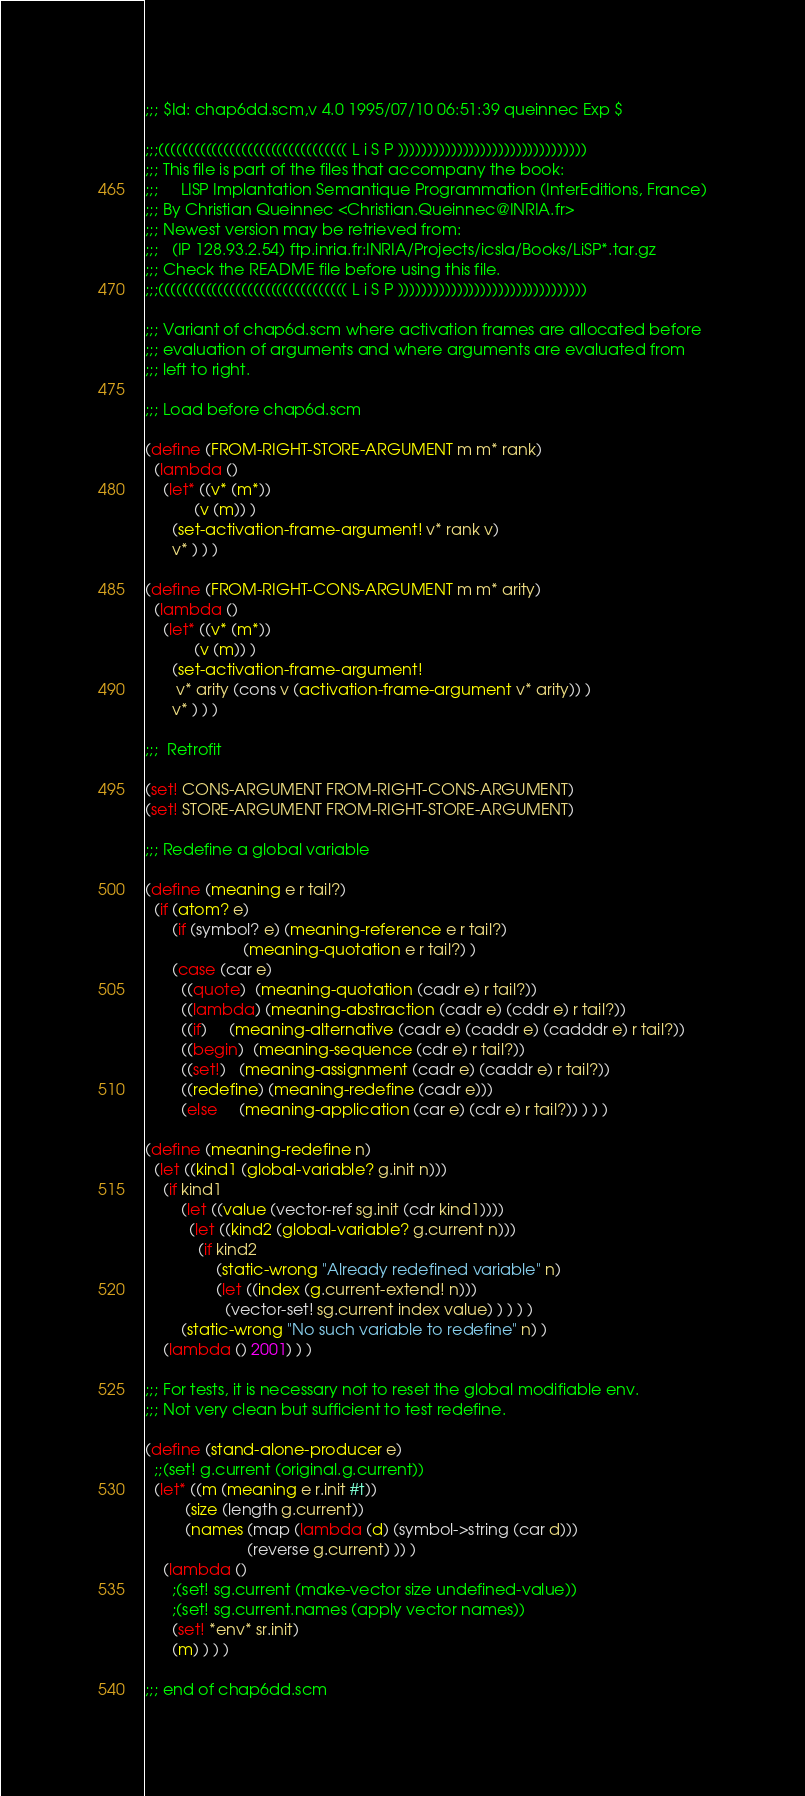<code> <loc_0><loc_0><loc_500><loc_500><_Scheme_>;;; $Id: chap6dd.scm,v 4.0 1995/07/10 06:51:39 queinnec Exp $

;;;(((((((((((((((((((((((((((((((( L i S P ))))))))))))))))))))))))))))))))
;;; This file is part of the files that accompany the book:
;;;     LISP Implantation Semantique Programmation (InterEditions, France)
;;; By Christian Queinnec <Christian.Queinnec@INRIA.fr>
;;; Newest version may be retrieved from:
;;;   (IP 128.93.2.54) ftp.inria.fr:INRIA/Projects/icsla/Books/LiSP*.tar.gz
;;; Check the README file before using this file.
;;;(((((((((((((((((((((((((((((((( L i S P ))))))))))))))))))))))))))))))))

;;; Variant of chap6d.scm where activation frames are allocated before
;;; evaluation of arguments and where arguments are evaluated from
;;; left to right.

;;; Load before chap6d.scm

(define (FROM-RIGHT-STORE-ARGUMENT m m* rank)
  (lambda ()
    (let* ((v* (m*))
           (v (m)) )
      (set-activation-frame-argument! v* rank v)
      v* ) ) )

(define (FROM-RIGHT-CONS-ARGUMENT m m* arity)
  (lambda ()
    (let* ((v* (m*))
           (v (m)) )
      (set-activation-frame-argument! 
       v* arity (cons v (activation-frame-argument v* arity)) )
      v* ) ) )

;;;  Retrofit

(set! CONS-ARGUMENT FROM-RIGHT-CONS-ARGUMENT)
(set! STORE-ARGUMENT FROM-RIGHT-STORE-ARGUMENT)

;;; Redefine a global variable

(define (meaning e r tail?)
  (if (atom? e)
      (if (symbol? e) (meaning-reference e r tail?)
                      (meaning-quotation e r tail?) )
      (case (car e)
        ((quote)  (meaning-quotation (cadr e) r tail?))
        ((lambda) (meaning-abstraction (cadr e) (cddr e) r tail?))
        ((if)     (meaning-alternative (cadr e) (caddr e) (cadddr e) r tail?))
        ((begin)  (meaning-sequence (cdr e) r tail?))
        ((set!)   (meaning-assignment (cadr e) (caddr e) r tail?))
        ((redefine) (meaning-redefine (cadr e)))
        (else     (meaning-application (car e) (cdr e) r tail?)) ) ) )

(define (meaning-redefine n)
  (let ((kind1 (global-variable? g.init n)))
    (if kind1
        (let ((value (vector-ref sg.init (cdr kind1))))
          (let ((kind2 (global-variable? g.current n)))
            (if kind2
                (static-wrong "Already redefined variable" n)
                (let ((index (g.current-extend! n)))
                  (vector-set! sg.current index value) ) ) ) )
        (static-wrong "No such variable to redefine" n) )
    (lambda () 2001) ) )

;;; For tests, it is necessary not to reset the global modifiable env.
;;; Not very clean but sufficient to test redefine.

(define (stand-alone-producer e)
  ;;(set! g.current (original.g.current))
  (let* ((m (meaning e r.init #t))
         (size (length g.current))
         (names (map (lambda (d) (symbol->string (car d)))
                       (reverse g.current) )) )
    (lambda ()
      ;(set! sg.current (make-vector size undefined-value))
      ;(set! sg.current.names (apply vector names))
      (set! *env* sr.init)
      (m) ) ) )

;;; end of chap6dd.scm
</code> 